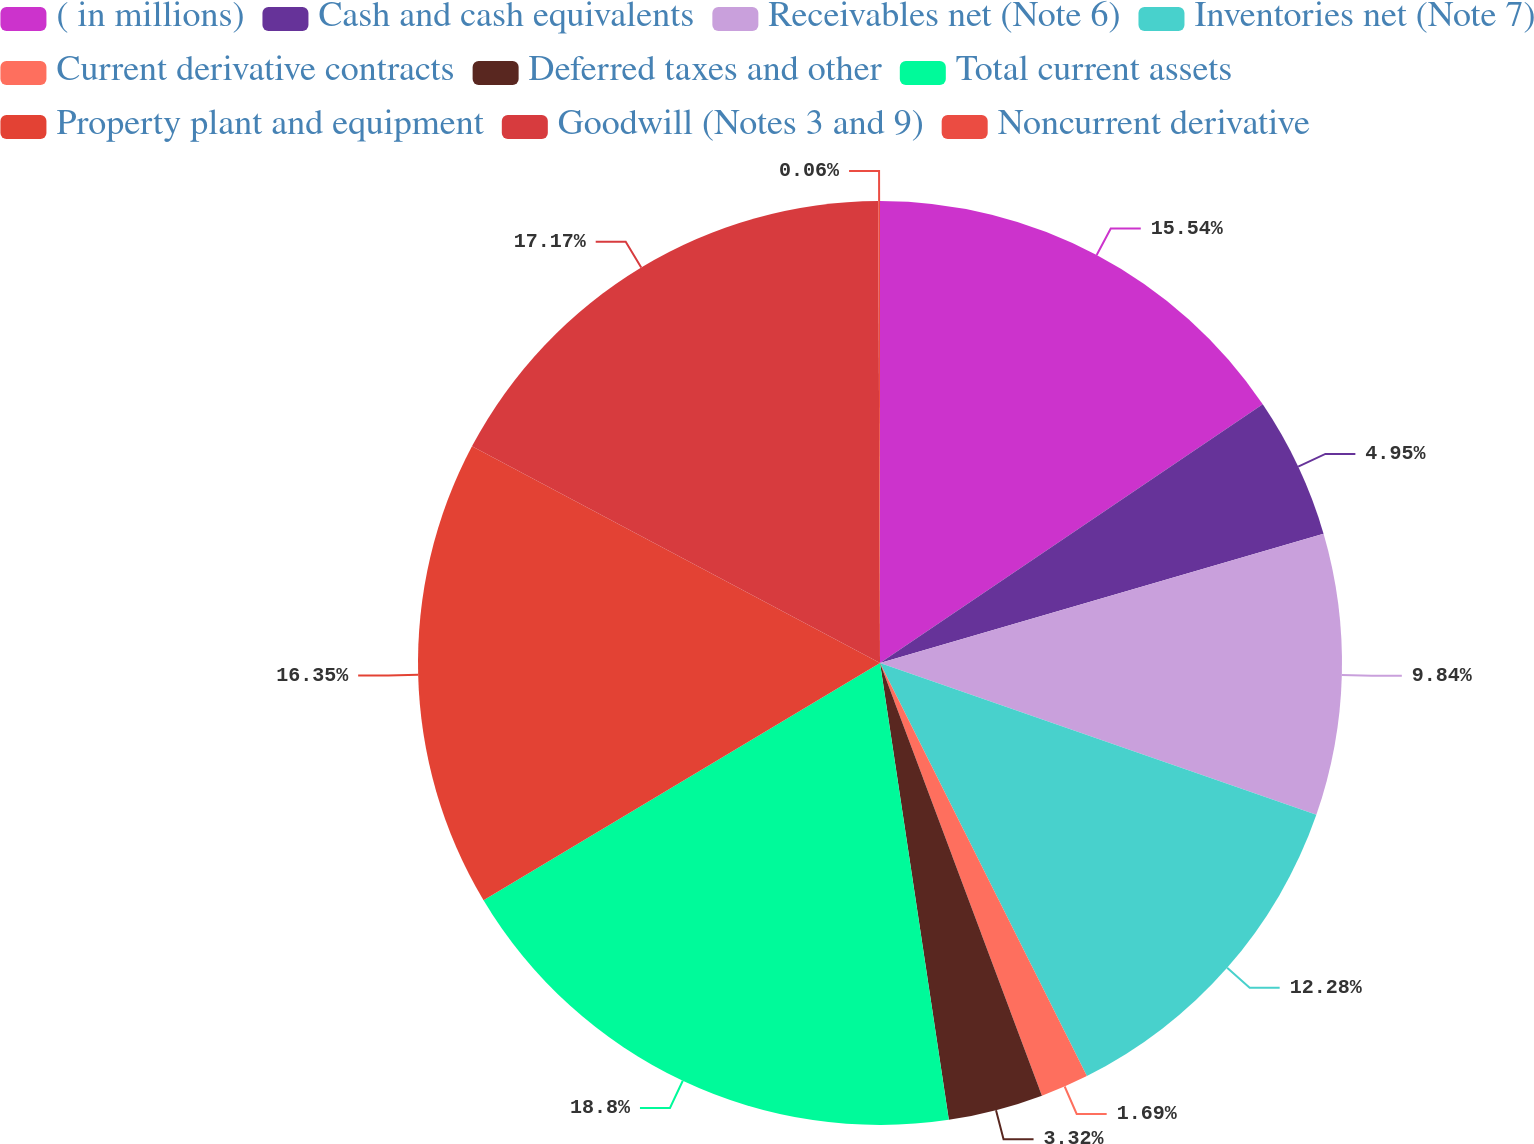<chart> <loc_0><loc_0><loc_500><loc_500><pie_chart><fcel>( in millions)<fcel>Cash and cash equivalents<fcel>Receivables net (Note 6)<fcel>Inventories net (Note 7)<fcel>Current derivative contracts<fcel>Deferred taxes and other<fcel>Total current assets<fcel>Property plant and equipment<fcel>Goodwill (Notes 3 and 9)<fcel>Noncurrent derivative<nl><fcel>15.54%<fcel>4.95%<fcel>9.84%<fcel>12.28%<fcel>1.69%<fcel>3.32%<fcel>18.8%<fcel>16.35%<fcel>17.17%<fcel>0.06%<nl></chart> 